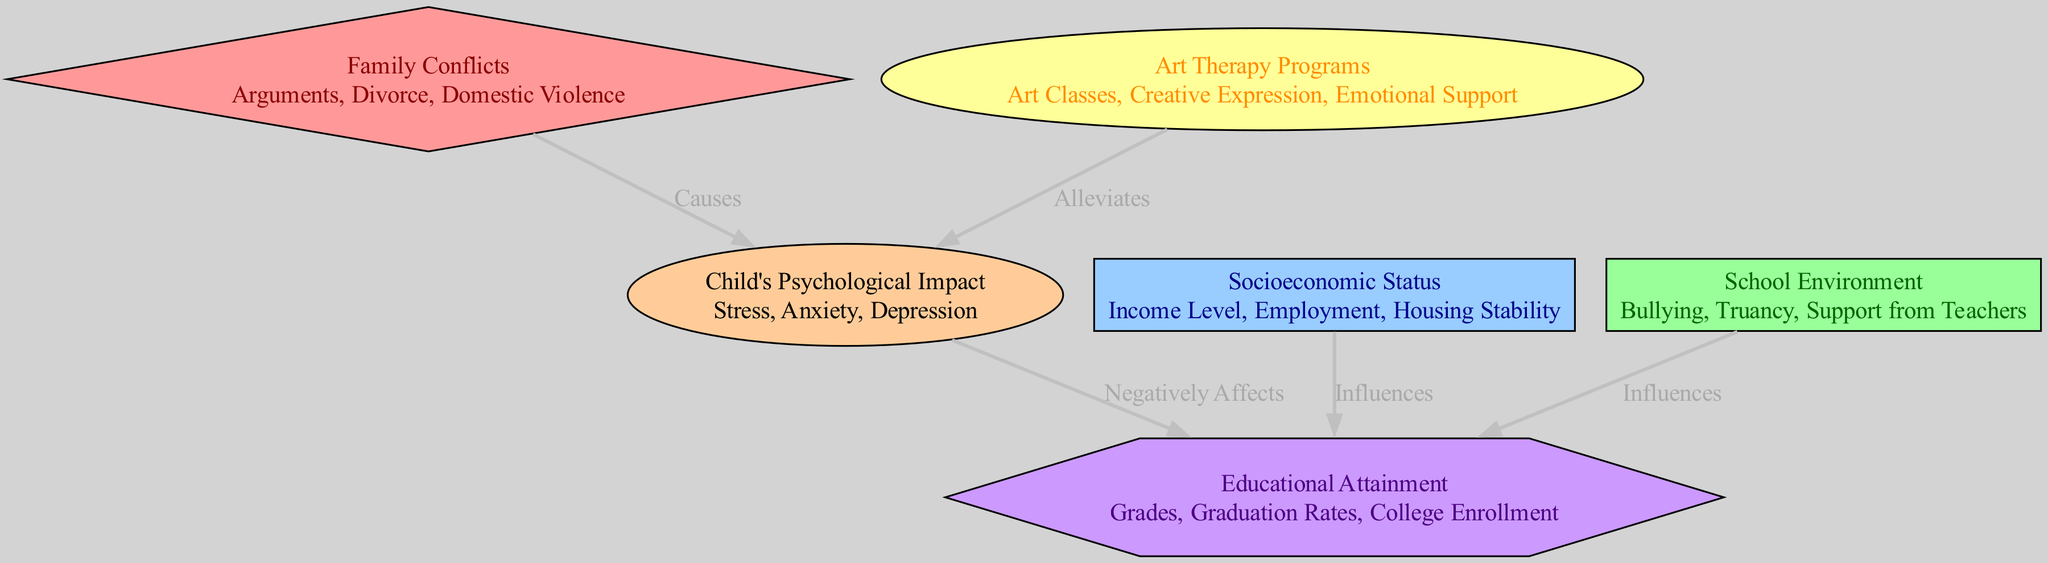What are the primary causes of children's psychological impact? The diagram indicates that "Family Conflicts" directly "Causes" the "Child's Psychological Impact." Thus, the primary causes include arguments, divorce, and domestic violence within the family.
Answer: Family Conflicts How many nodes are present in the diagram? The diagram lists six nodes: Family Conflicts, Child's Psychological Impact, Socioeconomic Status, School Environment, Educational Attainment, and Art Therapy Programs. Thus, there are six nodes in total.
Answer: 6 What negatively affects educational attainment? The diagram shows that the "Child's Psychological Impact" has a direct negative effect on "Educational Attainment." Therefore, the primary factor that negatively affects it is stress, anxiety, and depression experienced by the child.
Answer: Child's Psychological Impact Which node influences educational attainment alongside socioeconomic status? The diagram indicates that both "Socioeconomic Status" and "School Environment" influence "Educational Attainment." Since the question asks for another node besides socioeconomic status, it would be the school environment that has an influence as well.
Answer: School Environment What alleviates the child's psychological impact? The edge in the diagram asserts that "Art Therapy Programs" provide emotional support and therefore "Alleviates" the "Child's Psychological Impact." Hence, the factor that alleviates it is the implementation of art therapy programs.
Answer: Art Therapy Programs Which node represents the ultimate outcome in the diagram? The diagram culminates at the "Educational Attainment" node, which is influenced by factors like psychological impacts, socioeconomic status, and the school environment. Therefore, the ultimate outcome represented in the diagram is educational attainment.
Answer: Educational Attainment What type of relationship exists between family conflicts and child's psychological impact? The relationship shown in the diagram is that family conflicts "Causes" the child's psychological impact. This suggests a direct causal relationship between the two nodes.
Answer: Causes How many edges are shown in the diagram? There are five edges represented in the diagram, indicating the relationships between the different nodes that contribute to the overall theme.
Answer: 5 